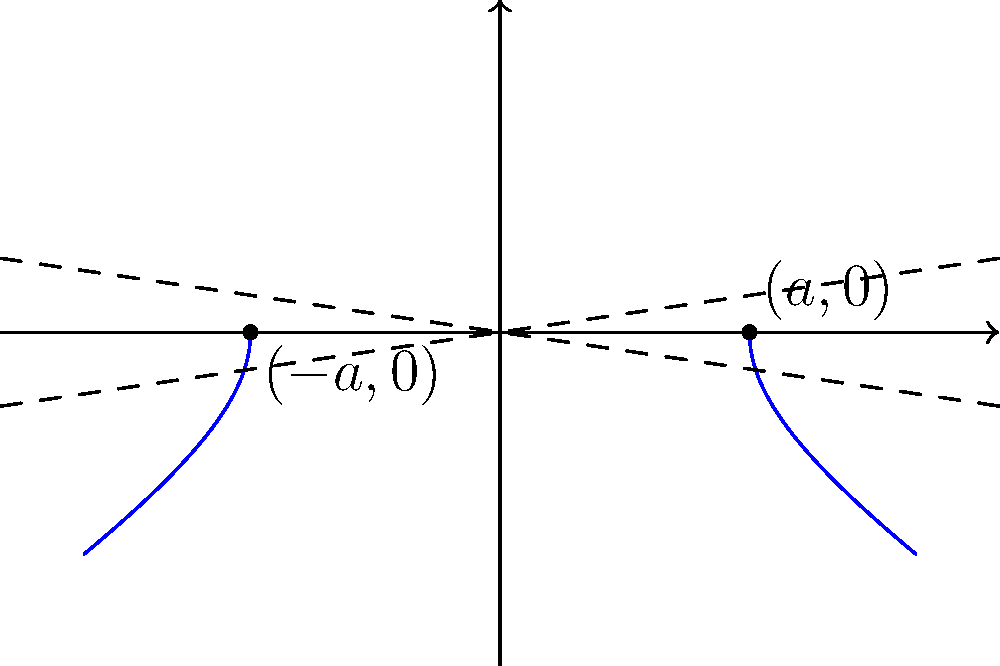Given a hyperbola with vertices at $(-3,0)$ and $(3,0)$, and asymptotes described by the equations $y = \pm \frac{2}{3}x$, determine the standard form equation of the hyperbola. How might this relate to regulatory frameworks impacting entrepreneurial ventures in terms of constraints and growth potential? Let's approach this step-by-step:

1) The standard form of a hyperbola with center at the origin and transverse axis along the x-axis is:

   $$\frac{x^2}{a^2} - \frac{y^2}{b^2} = 1$$

2) From the vertices, we can determine that $a = 3$, as the vertices are located at $(\pm a, 0)$.

3) The equation of the asymptotes for this form of hyperbola is $y = \pm \frac{b}{a}x$. We're given that the asymptotes are $y = \pm \frac{2}{3}x$, so:

   $$\frac{b}{a} = \frac{2}{3}$$

4) Since we know $a = 3$, we can solve for $b$:

   $$b = a \cdot \frac{2}{3} = 3 \cdot \frac{2}{3} = 2$$

5) Now we have both $a$ and $b$, we can substitute these into the standard form:

   $$\frac{x^2}{3^2} - \frac{y^2}{2^2} = 1$$

6) Simplifying:

   $$\frac{x^2}{9} - \frac{y^2}{4} = 1$$

This equation represents the hyperbola given in the question.

Relating to regulatory frameworks and entrepreneurial ventures:
- The vertices $(\pm a, 0)$ could represent the maximum constraints or opportunities within the regulatory framework.
- The asymptotes could symbolize the long-term growth trajectories or limits that ventures might approach but never exceed due to regulatory constraints.
- The shape of the hyperbola itself might represent how ventures can grow rapidly within certain bounds but face increasing regulatory challenges as they expand.
Answer: $$\frac{x^2}{9} - \frac{y^2}{4} = 1$$ 